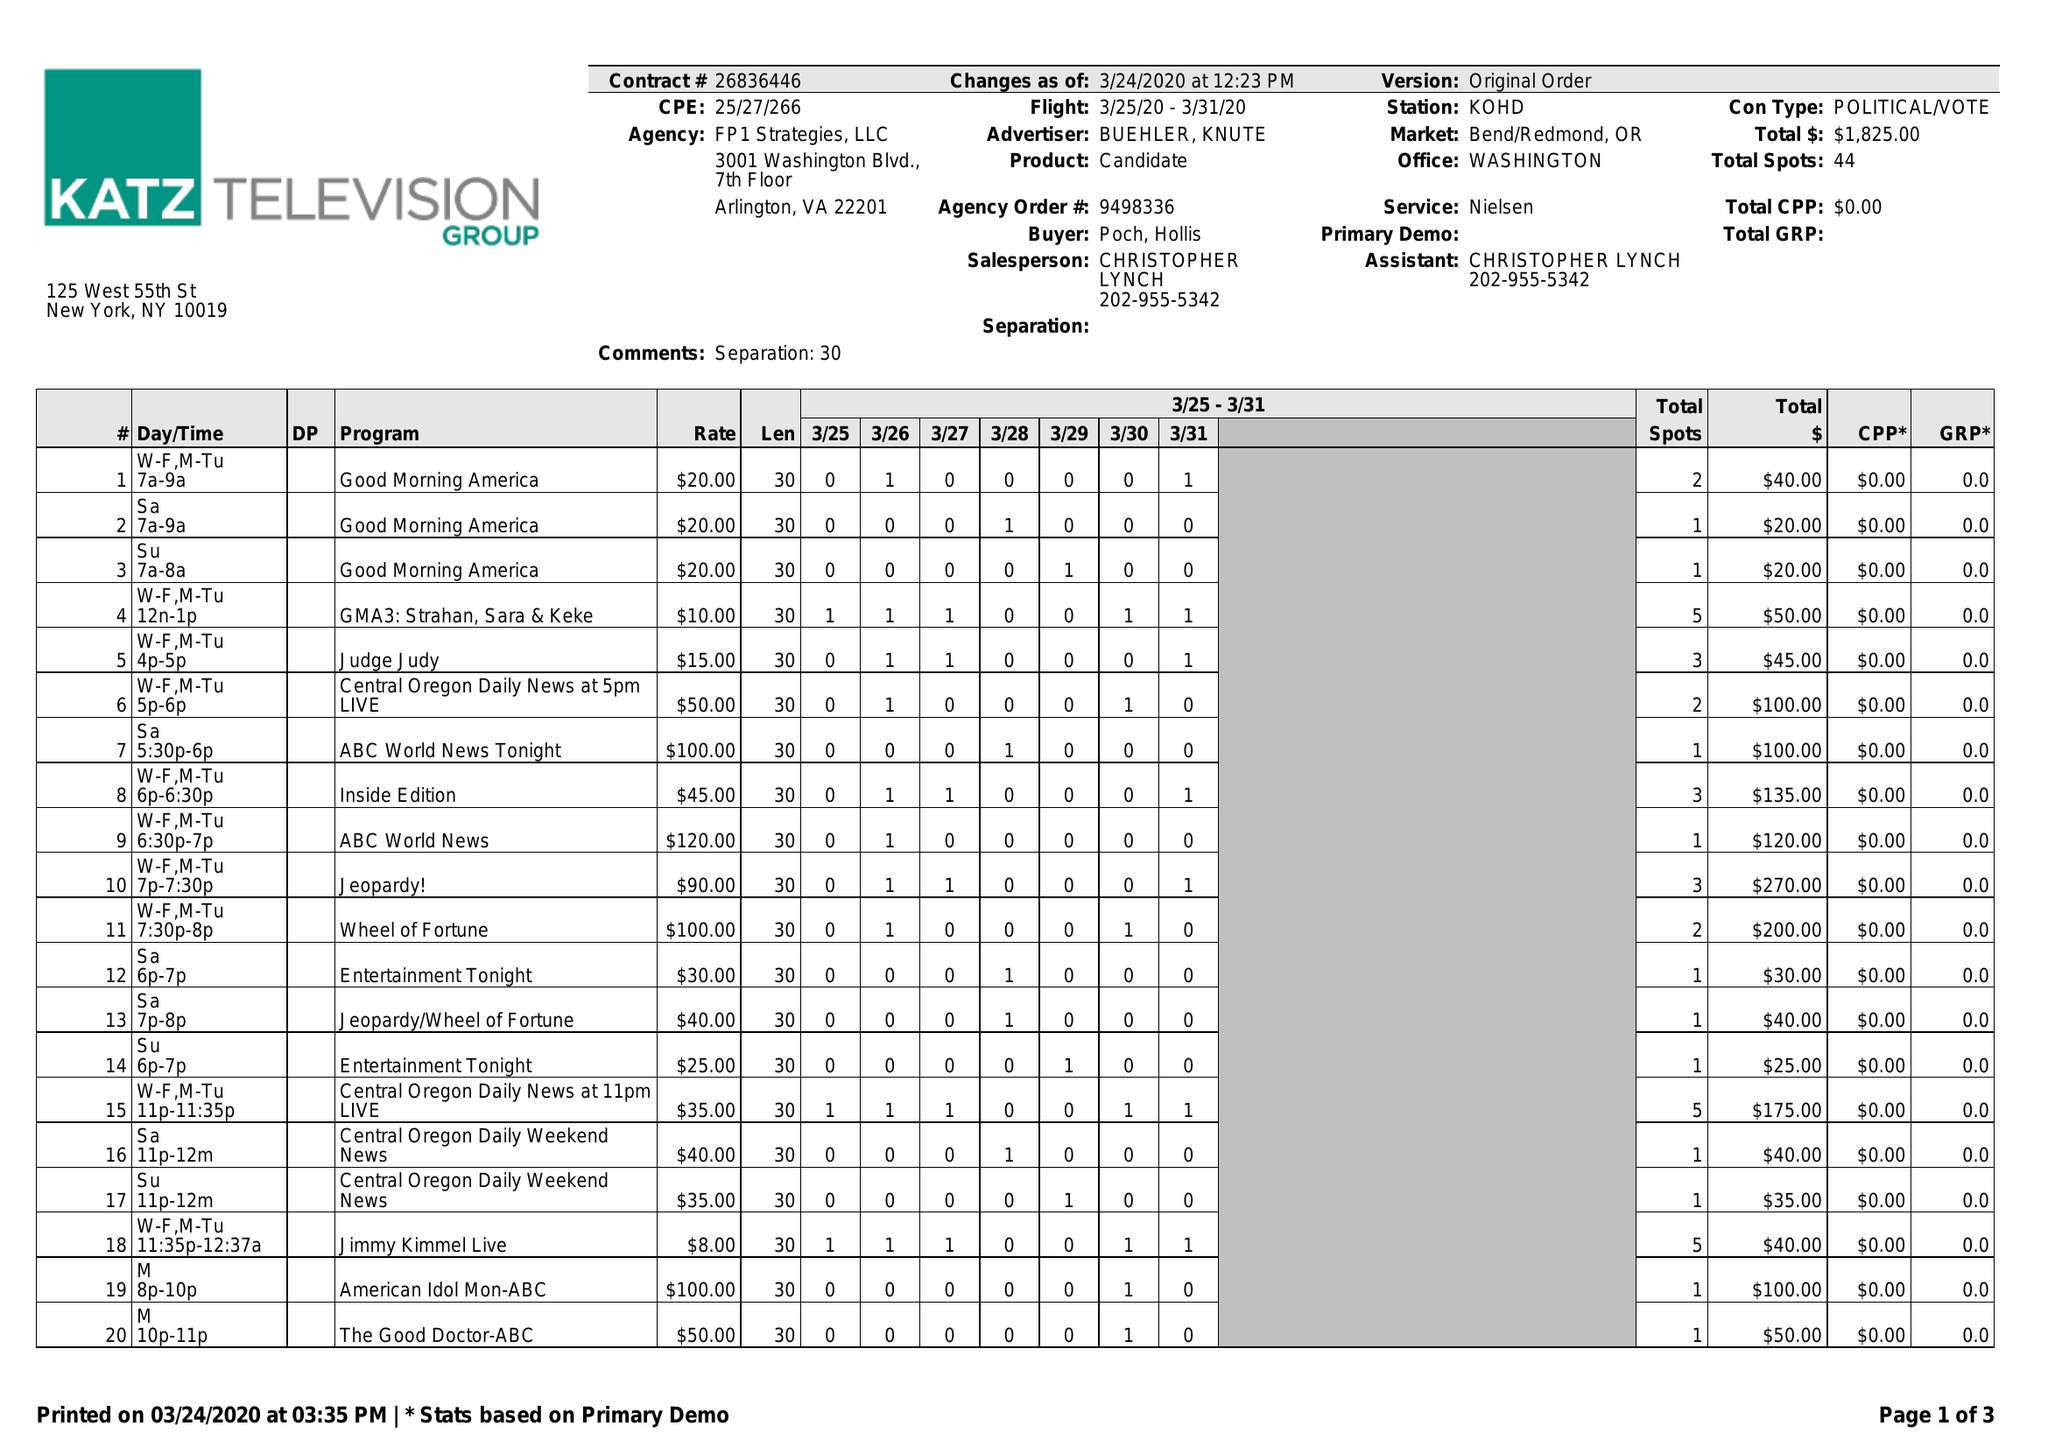What is the value for the flight_to?
Answer the question using a single word or phrase. 03/31/20 